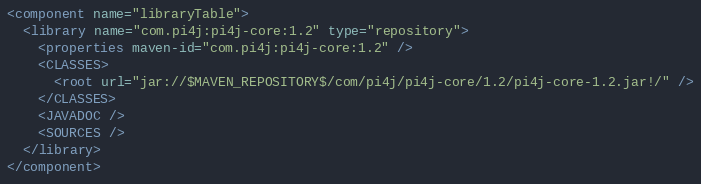<code> <loc_0><loc_0><loc_500><loc_500><_XML_><component name="libraryTable">
  <library name="com.pi4j:pi4j-core:1.2" type="repository">
    <properties maven-id="com.pi4j:pi4j-core:1.2" />
    <CLASSES>
      <root url="jar://$MAVEN_REPOSITORY$/com/pi4j/pi4j-core/1.2/pi4j-core-1.2.jar!/" />
    </CLASSES>
    <JAVADOC />
    <SOURCES />
  </library>
</component></code> 